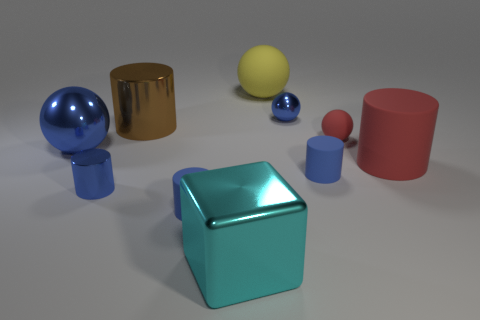Subtract all purple balls. How many blue cylinders are left? 3 Subtract all red cylinders. How many cylinders are left? 4 Subtract all purple cylinders. Subtract all brown spheres. How many cylinders are left? 5 Subtract all balls. How many objects are left? 6 Subtract all brown cylinders. Subtract all tiny cyan things. How many objects are left? 9 Add 6 large cyan metal cubes. How many large cyan metal cubes are left? 7 Add 1 small cyan blocks. How many small cyan blocks exist? 1 Subtract 0 gray spheres. How many objects are left? 10 